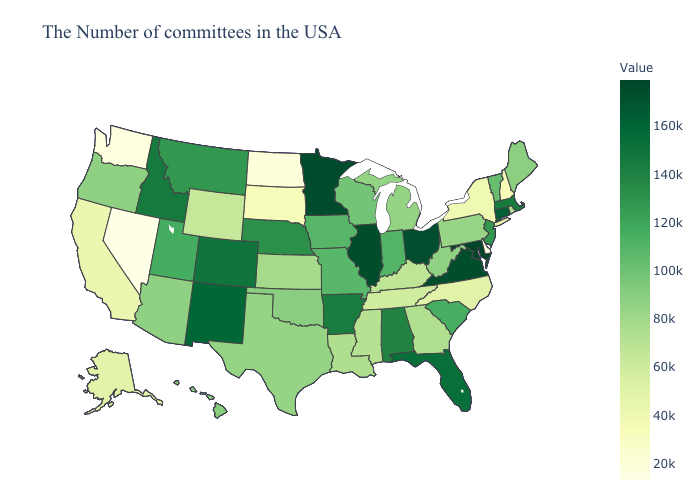Does Nevada have the lowest value in the USA?
Keep it brief. Yes. Does Arkansas have a lower value than North Dakota?
Answer briefly. No. Does the map have missing data?
Short answer required. No. 